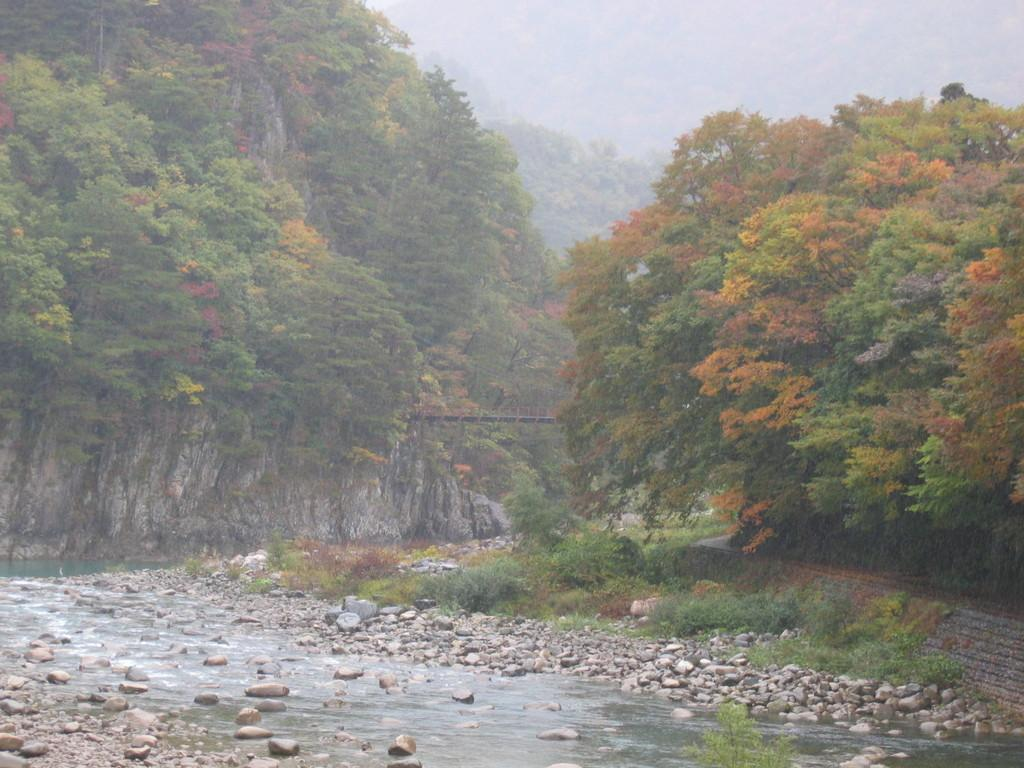What type of natural elements can be seen in the image? There is a group of trees, plants, and stones visible in the image. What is the water body situated under in the image? The water body is under a bridge in the image. What is the condition of the sky in the image? The sky is visible in the image and appears cloudy. What type of food is being served on the bridge in the image? There is no food or any indication of food being served in the image. What type of quartz can be seen in the image? There is no quartz present in the image. 